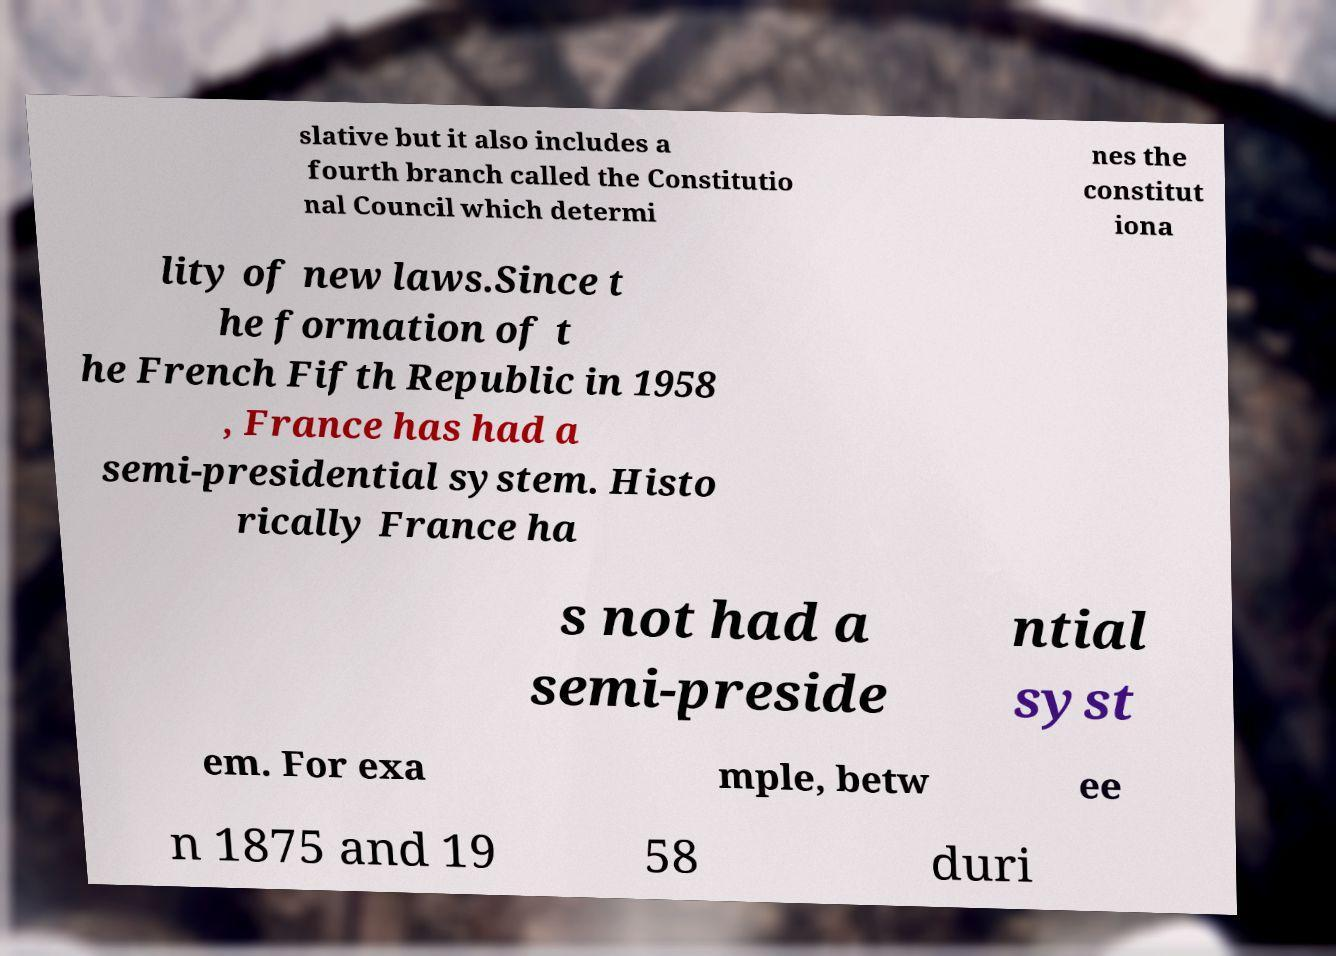There's text embedded in this image that I need extracted. Can you transcribe it verbatim? slative but it also includes a fourth branch called the Constitutio nal Council which determi nes the constitut iona lity of new laws.Since t he formation of t he French Fifth Republic in 1958 , France has had a semi-presidential system. Histo rically France ha s not had a semi-preside ntial syst em. For exa mple, betw ee n 1875 and 19 58 duri 